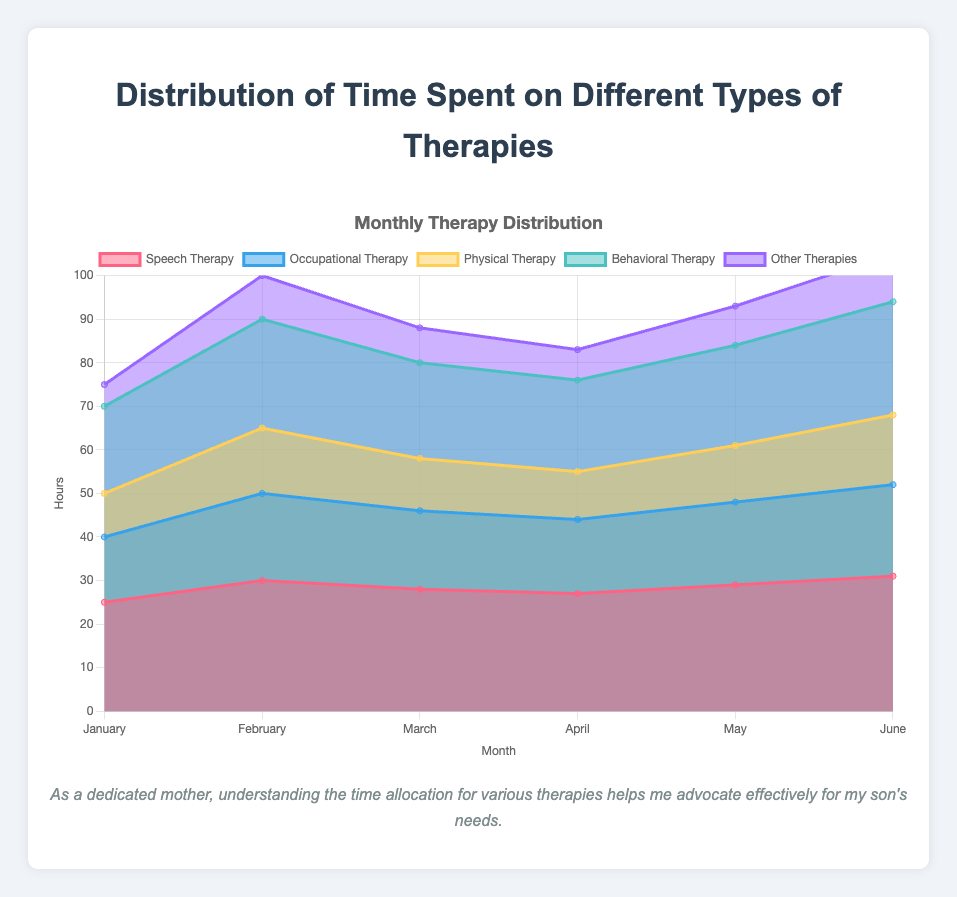What is the title of the chart? The title of the chart is displayed at the top and provides an overview of what the chart represents. In this case, it is "Distribution of Time Spent on Different Types of Therapies."
Answer: Distribution of Time Spent on Different Types of Therapies How many different types of therapies are tracked in the chart? The chart tracks different therapies, each represented by a distinct color. There are five different types: Speech Therapy, Occupational Therapy, Physical Therapy, Behavioral Therapy, and Other Therapies.
Answer: Five Which month shows the highest total number of hours spent on therapies? To find the month with the highest total hours, add the values of all therapies for each month. June has the highest total with a sum of (31 + 21 + 16 + 26 + 11) = 105 hours.
Answer: June How do the hours spent on Speech Therapy change from January to June? Look at the line representing Speech Therapy and check the data points from January to June: January (25), February (30), March (28), April (27), May (29), June (31). There is an overall increasing trend in the hours spent on Speech Therapy from 25 in January to 31 in June.
Answer: It increases What is the difference in hours spent on Physical Therapy between February and April? Check the data points for Physical Therapy in February and April: February (15), April (11). Subtract April's value from February’s (15 - 11).
Answer: 4 hours In which month is the least amount of time spent on Behavioral Therapy? Look at the data points for Behavioral Therapy: January (20), February (25), March (22), April (21), May (23), June (26). The smallest value is in January with 20 hours.
Answer: January Which therapy had the highest number of hours in March? Compare the values for each therapy in March: Speech Therapy (28), Occupational Therapy (18), Physical Therapy (12), Behavioral Therapy (22), Other Therapies (8). Speech Therapy has the highest number of hours at 28.
Answer: Speech Therapy How much time is spent on Other Therapies in February compared to May? Check the data points for Other Therapies in both months: February (10), May (9). Subtract May's value from February's (10 - 9).
Answer: 1 hour more in February Do the hours spent on Occupational Therapy show an increasing or decreasing trend from January to June? Check the data points for Occupational Therapy: January (15), February (20), March (18), April (17), May (19), June (21). While there are some fluctuations, overall there is an increasing trend from 15 in January to 21 in June.
Answer: Increasing Which month shows the least number of hours spent across all therapies? Add the hours for each therapy across all months and find the month with the smallest total. January has the lowest sum: (25 + 15 + 10 + 20 + 5) = 75 hours.
Answer: January 